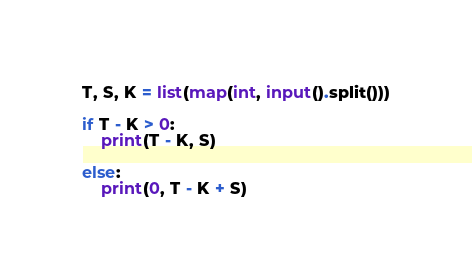Convert code to text. <code><loc_0><loc_0><loc_500><loc_500><_Python_>T, S, K = list(map(int, input().split()))

if T - K > 0:
    print(T - K, S)

else:
    print(0, T - K + S)
</code> 